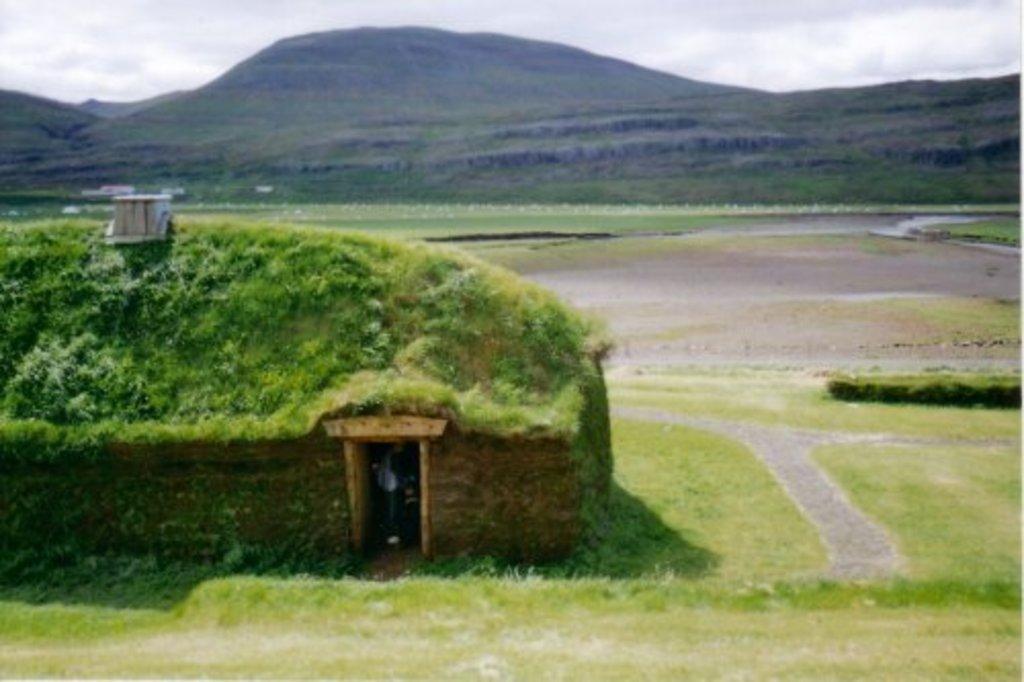Please provide a concise description of this image. In this image there is grass on the ground. To the left there is a house. There are plants on the roof of the house. In the background there are mountains. At the top there is the sky. 